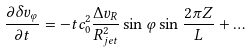<formula> <loc_0><loc_0><loc_500><loc_500>\frac { \partial \delta v _ { \varphi } } { \partial t } = - t c ^ { 2 } _ { 0 } \frac { \Delta v _ { R } } { R ^ { 2 } _ { j e t } } \sin { \varphi } \sin \frac { 2 \pi Z } { L } + \dots</formula> 